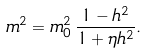<formula> <loc_0><loc_0><loc_500><loc_500>m ^ { 2 } = m _ { 0 } ^ { 2 } \, \frac { 1 - h ^ { 2 } } { 1 + \eta h ^ { 2 } } .</formula> 